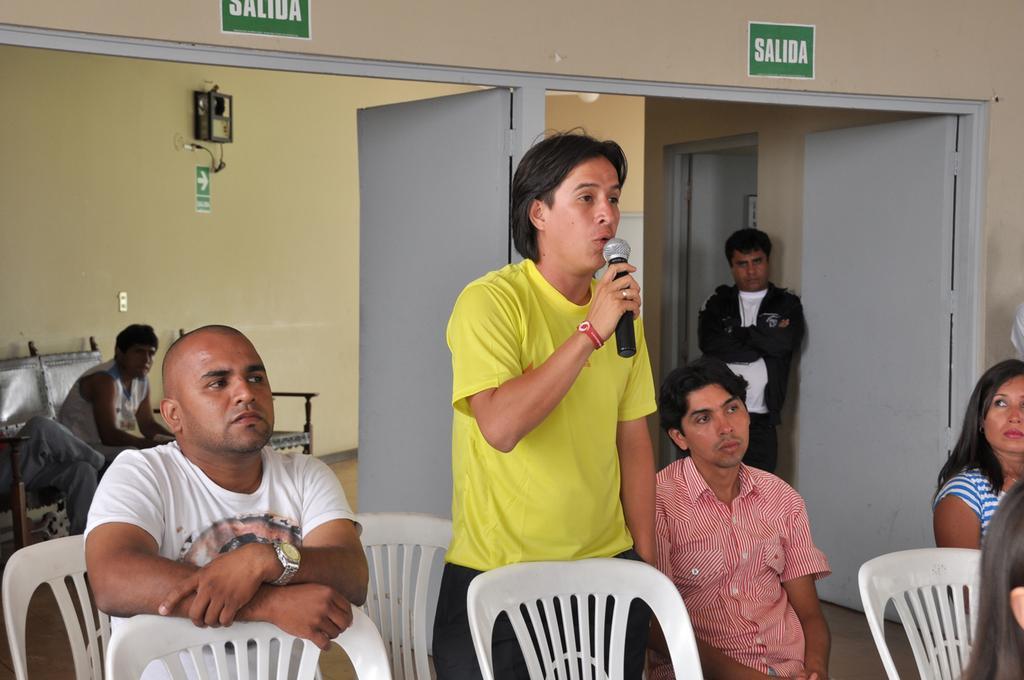How would you summarize this image in a sentence or two? In this image i can see three man and a woman a man in the middle is standing and holding microphone at the right the woman is sitting at the back ground i can see a man standing a door and a woman sitting in a couch a wall. 